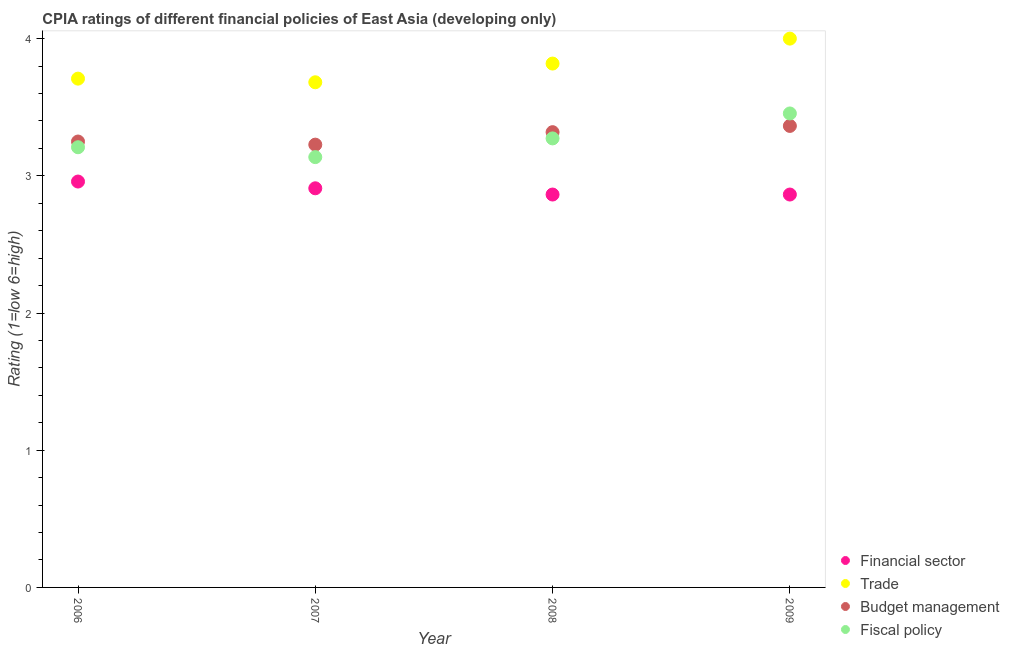Is the number of dotlines equal to the number of legend labels?
Provide a short and direct response. Yes. What is the cpia rating of fiscal policy in 2008?
Offer a terse response. 3.27. Across all years, what is the minimum cpia rating of budget management?
Keep it short and to the point. 3.23. In which year was the cpia rating of fiscal policy maximum?
Offer a terse response. 2009. What is the total cpia rating of financial sector in the graph?
Provide a short and direct response. 11.59. What is the difference between the cpia rating of budget management in 2007 and that in 2009?
Your response must be concise. -0.14. What is the difference between the cpia rating of budget management in 2007 and the cpia rating of fiscal policy in 2009?
Offer a terse response. -0.23. What is the average cpia rating of financial sector per year?
Make the answer very short. 2.9. In how many years, is the cpia rating of financial sector greater than 3.8?
Ensure brevity in your answer.  0. What is the ratio of the cpia rating of financial sector in 2007 to that in 2008?
Provide a short and direct response. 1.02. Is the cpia rating of trade in 2006 less than that in 2008?
Ensure brevity in your answer.  Yes. What is the difference between the highest and the second highest cpia rating of fiscal policy?
Make the answer very short. 0.18. What is the difference between the highest and the lowest cpia rating of trade?
Offer a terse response. 0.32. Is it the case that in every year, the sum of the cpia rating of financial sector and cpia rating of trade is greater than the cpia rating of budget management?
Provide a succinct answer. Yes. How many dotlines are there?
Give a very brief answer. 4. How many years are there in the graph?
Keep it short and to the point. 4. What is the difference between two consecutive major ticks on the Y-axis?
Keep it short and to the point. 1. Does the graph contain any zero values?
Your answer should be compact. No. How are the legend labels stacked?
Your answer should be compact. Vertical. What is the title of the graph?
Your response must be concise. CPIA ratings of different financial policies of East Asia (developing only). What is the Rating (1=low 6=high) in Financial sector in 2006?
Ensure brevity in your answer.  2.96. What is the Rating (1=low 6=high) of Trade in 2006?
Keep it short and to the point. 3.71. What is the Rating (1=low 6=high) of Fiscal policy in 2006?
Ensure brevity in your answer.  3.21. What is the Rating (1=low 6=high) in Financial sector in 2007?
Offer a terse response. 2.91. What is the Rating (1=low 6=high) in Trade in 2007?
Make the answer very short. 3.68. What is the Rating (1=low 6=high) in Budget management in 2007?
Ensure brevity in your answer.  3.23. What is the Rating (1=low 6=high) of Fiscal policy in 2007?
Your answer should be compact. 3.14. What is the Rating (1=low 6=high) in Financial sector in 2008?
Give a very brief answer. 2.86. What is the Rating (1=low 6=high) in Trade in 2008?
Ensure brevity in your answer.  3.82. What is the Rating (1=low 6=high) in Budget management in 2008?
Keep it short and to the point. 3.32. What is the Rating (1=low 6=high) in Fiscal policy in 2008?
Ensure brevity in your answer.  3.27. What is the Rating (1=low 6=high) in Financial sector in 2009?
Make the answer very short. 2.86. What is the Rating (1=low 6=high) in Budget management in 2009?
Give a very brief answer. 3.36. What is the Rating (1=low 6=high) in Fiscal policy in 2009?
Your response must be concise. 3.45. Across all years, what is the maximum Rating (1=low 6=high) of Financial sector?
Provide a short and direct response. 2.96. Across all years, what is the maximum Rating (1=low 6=high) in Trade?
Provide a short and direct response. 4. Across all years, what is the maximum Rating (1=low 6=high) of Budget management?
Make the answer very short. 3.36. Across all years, what is the maximum Rating (1=low 6=high) of Fiscal policy?
Your answer should be very brief. 3.45. Across all years, what is the minimum Rating (1=low 6=high) of Financial sector?
Your answer should be compact. 2.86. Across all years, what is the minimum Rating (1=low 6=high) in Trade?
Your answer should be compact. 3.68. Across all years, what is the minimum Rating (1=low 6=high) in Budget management?
Your answer should be very brief. 3.23. Across all years, what is the minimum Rating (1=low 6=high) of Fiscal policy?
Your answer should be very brief. 3.14. What is the total Rating (1=low 6=high) of Financial sector in the graph?
Your answer should be very brief. 11.59. What is the total Rating (1=low 6=high) of Trade in the graph?
Provide a succinct answer. 15.21. What is the total Rating (1=low 6=high) of Budget management in the graph?
Offer a terse response. 13.16. What is the total Rating (1=low 6=high) of Fiscal policy in the graph?
Make the answer very short. 13.07. What is the difference between the Rating (1=low 6=high) of Financial sector in 2006 and that in 2007?
Give a very brief answer. 0.05. What is the difference between the Rating (1=low 6=high) in Trade in 2006 and that in 2007?
Make the answer very short. 0.03. What is the difference between the Rating (1=low 6=high) of Budget management in 2006 and that in 2007?
Provide a short and direct response. 0.02. What is the difference between the Rating (1=low 6=high) of Fiscal policy in 2006 and that in 2007?
Keep it short and to the point. 0.07. What is the difference between the Rating (1=low 6=high) of Financial sector in 2006 and that in 2008?
Give a very brief answer. 0.09. What is the difference between the Rating (1=low 6=high) in Trade in 2006 and that in 2008?
Offer a very short reply. -0.11. What is the difference between the Rating (1=low 6=high) in Budget management in 2006 and that in 2008?
Provide a succinct answer. -0.07. What is the difference between the Rating (1=low 6=high) of Fiscal policy in 2006 and that in 2008?
Your answer should be compact. -0.06. What is the difference between the Rating (1=low 6=high) of Financial sector in 2006 and that in 2009?
Give a very brief answer. 0.09. What is the difference between the Rating (1=low 6=high) in Trade in 2006 and that in 2009?
Offer a terse response. -0.29. What is the difference between the Rating (1=low 6=high) of Budget management in 2006 and that in 2009?
Give a very brief answer. -0.11. What is the difference between the Rating (1=low 6=high) of Fiscal policy in 2006 and that in 2009?
Offer a very short reply. -0.25. What is the difference between the Rating (1=low 6=high) of Financial sector in 2007 and that in 2008?
Your answer should be compact. 0.05. What is the difference between the Rating (1=low 6=high) in Trade in 2007 and that in 2008?
Provide a short and direct response. -0.14. What is the difference between the Rating (1=low 6=high) of Budget management in 2007 and that in 2008?
Provide a succinct answer. -0.09. What is the difference between the Rating (1=low 6=high) of Fiscal policy in 2007 and that in 2008?
Ensure brevity in your answer.  -0.14. What is the difference between the Rating (1=low 6=high) in Financial sector in 2007 and that in 2009?
Provide a succinct answer. 0.05. What is the difference between the Rating (1=low 6=high) of Trade in 2007 and that in 2009?
Make the answer very short. -0.32. What is the difference between the Rating (1=low 6=high) in Budget management in 2007 and that in 2009?
Offer a very short reply. -0.14. What is the difference between the Rating (1=low 6=high) of Fiscal policy in 2007 and that in 2009?
Your answer should be very brief. -0.32. What is the difference between the Rating (1=low 6=high) of Trade in 2008 and that in 2009?
Offer a terse response. -0.18. What is the difference between the Rating (1=low 6=high) in Budget management in 2008 and that in 2009?
Ensure brevity in your answer.  -0.05. What is the difference between the Rating (1=low 6=high) of Fiscal policy in 2008 and that in 2009?
Offer a very short reply. -0.18. What is the difference between the Rating (1=low 6=high) in Financial sector in 2006 and the Rating (1=low 6=high) in Trade in 2007?
Offer a terse response. -0.72. What is the difference between the Rating (1=low 6=high) of Financial sector in 2006 and the Rating (1=low 6=high) of Budget management in 2007?
Make the answer very short. -0.27. What is the difference between the Rating (1=low 6=high) in Financial sector in 2006 and the Rating (1=low 6=high) in Fiscal policy in 2007?
Provide a succinct answer. -0.18. What is the difference between the Rating (1=low 6=high) in Trade in 2006 and the Rating (1=low 6=high) in Budget management in 2007?
Offer a very short reply. 0.48. What is the difference between the Rating (1=low 6=high) of Trade in 2006 and the Rating (1=low 6=high) of Fiscal policy in 2007?
Your answer should be very brief. 0.57. What is the difference between the Rating (1=low 6=high) of Budget management in 2006 and the Rating (1=low 6=high) of Fiscal policy in 2007?
Your response must be concise. 0.11. What is the difference between the Rating (1=low 6=high) in Financial sector in 2006 and the Rating (1=low 6=high) in Trade in 2008?
Give a very brief answer. -0.86. What is the difference between the Rating (1=low 6=high) of Financial sector in 2006 and the Rating (1=low 6=high) of Budget management in 2008?
Your answer should be very brief. -0.36. What is the difference between the Rating (1=low 6=high) of Financial sector in 2006 and the Rating (1=low 6=high) of Fiscal policy in 2008?
Offer a very short reply. -0.31. What is the difference between the Rating (1=low 6=high) in Trade in 2006 and the Rating (1=low 6=high) in Budget management in 2008?
Offer a very short reply. 0.39. What is the difference between the Rating (1=low 6=high) in Trade in 2006 and the Rating (1=low 6=high) in Fiscal policy in 2008?
Offer a very short reply. 0.44. What is the difference between the Rating (1=low 6=high) in Budget management in 2006 and the Rating (1=low 6=high) in Fiscal policy in 2008?
Keep it short and to the point. -0.02. What is the difference between the Rating (1=low 6=high) in Financial sector in 2006 and the Rating (1=low 6=high) in Trade in 2009?
Give a very brief answer. -1.04. What is the difference between the Rating (1=low 6=high) of Financial sector in 2006 and the Rating (1=low 6=high) of Budget management in 2009?
Your answer should be compact. -0.41. What is the difference between the Rating (1=low 6=high) in Financial sector in 2006 and the Rating (1=low 6=high) in Fiscal policy in 2009?
Provide a short and direct response. -0.5. What is the difference between the Rating (1=low 6=high) of Trade in 2006 and the Rating (1=low 6=high) of Budget management in 2009?
Offer a very short reply. 0.34. What is the difference between the Rating (1=low 6=high) in Trade in 2006 and the Rating (1=low 6=high) in Fiscal policy in 2009?
Offer a terse response. 0.25. What is the difference between the Rating (1=low 6=high) in Budget management in 2006 and the Rating (1=low 6=high) in Fiscal policy in 2009?
Provide a succinct answer. -0.2. What is the difference between the Rating (1=low 6=high) in Financial sector in 2007 and the Rating (1=low 6=high) in Trade in 2008?
Make the answer very short. -0.91. What is the difference between the Rating (1=low 6=high) in Financial sector in 2007 and the Rating (1=low 6=high) in Budget management in 2008?
Your response must be concise. -0.41. What is the difference between the Rating (1=low 6=high) of Financial sector in 2007 and the Rating (1=low 6=high) of Fiscal policy in 2008?
Ensure brevity in your answer.  -0.36. What is the difference between the Rating (1=low 6=high) in Trade in 2007 and the Rating (1=low 6=high) in Budget management in 2008?
Your response must be concise. 0.36. What is the difference between the Rating (1=low 6=high) of Trade in 2007 and the Rating (1=low 6=high) of Fiscal policy in 2008?
Provide a short and direct response. 0.41. What is the difference between the Rating (1=low 6=high) in Budget management in 2007 and the Rating (1=low 6=high) in Fiscal policy in 2008?
Offer a very short reply. -0.05. What is the difference between the Rating (1=low 6=high) in Financial sector in 2007 and the Rating (1=low 6=high) in Trade in 2009?
Provide a succinct answer. -1.09. What is the difference between the Rating (1=low 6=high) of Financial sector in 2007 and the Rating (1=low 6=high) of Budget management in 2009?
Provide a short and direct response. -0.45. What is the difference between the Rating (1=low 6=high) of Financial sector in 2007 and the Rating (1=low 6=high) of Fiscal policy in 2009?
Keep it short and to the point. -0.55. What is the difference between the Rating (1=low 6=high) of Trade in 2007 and the Rating (1=low 6=high) of Budget management in 2009?
Offer a very short reply. 0.32. What is the difference between the Rating (1=low 6=high) of Trade in 2007 and the Rating (1=low 6=high) of Fiscal policy in 2009?
Offer a terse response. 0.23. What is the difference between the Rating (1=low 6=high) in Budget management in 2007 and the Rating (1=low 6=high) in Fiscal policy in 2009?
Offer a very short reply. -0.23. What is the difference between the Rating (1=low 6=high) in Financial sector in 2008 and the Rating (1=low 6=high) in Trade in 2009?
Offer a very short reply. -1.14. What is the difference between the Rating (1=low 6=high) in Financial sector in 2008 and the Rating (1=low 6=high) in Fiscal policy in 2009?
Make the answer very short. -0.59. What is the difference between the Rating (1=low 6=high) of Trade in 2008 and the Rating (1=low 6=high) of Budget management in 2009?
Give a very brief answer. 0.45. What is the difference between the Rating (1=low 6=high) of Trade in 2008 and the Rating (1=low 6=high) of Fiscal policy in 2009?
Provide a short and direct response. 0.36. What is the difference between the Rating (1=low 6=high) in Budget management in 2008 and the Rating (1=low 6=high) in Fiscal policy in 2009?
Provide a short and direct response. -0.14. What is the average Rating (1=low 6=high) of Financial sector per year?
Give a very brief answer. 2.9. What is the average Rating (1=low 6=high) of Trade per year?
Your response must be concise. 3.8. What is the average Rating (1=low 6=high) in Budget management per year?
Provide a succinct answer. 3.29. What is the average Rating (1=low 6=high) in Fiscal policy per year?
Your response must be concise. 3.27. In the year 2006, what is the difference between the Rating (1=low 6=high) in Financial sector and Rating (1=low 6=high) in Trade?
Make the answer very short. -0.75. In the year 2006, what is the difference between the Rating (1=low 6=high) of Financial sector and Rating (1=low 6=high) of Budget management?
Make the answer very short. -0.29. In the year 2006, what is the difference between the Rating (1=low 6=high) of Trade and Rating (1=low 6=high) of Budget management?
Ensure brevity in your answer.  0.46. In the year 2006, what is the difference between the Rating (1=low 6=high) in Budget management and Rating (1=low 6=high) in Fiscal policy?
Ensure brevity in your answer.  0.04. In the year 2007, what is the difference between the Rating (1=low 6=high) of Financial sector and Rating (1=low 6=high) of Trade?
Your response must be concise. -0.77. In the year 2007, what is the difference between the Rating (1=low 6=high) of Financial sector and Rating (1=low 6=high) of Budget management?
Offer a very short reply. -0.32. In the year 2007, what is the difference between the Rating (1=low 6=high) in Financial sector and Rating (1=low 6=high) in Fiscal policy?
Offer a terse response. -0.23. In the year 2007, what is the difference between the Rating (1=low 6=high) of Trade and Rating (1=low 6=high) of Budget management?
Provide a succinct answer. 0.45. In the year 2007, what is the difference between the Rating (1=low 6=high) of Trade and Rating (1=low 6=high) of Fiscal policy?
Keep it short and to the point. 0.55. In the year 2007, what is the difference between the Rating (1=low 6=high) of Budget management and Rating (1=low 6=high) of Fiscal policy?
Keep it short and to the point. 0.09. In the year 2008, what is the difference between the Rating (1=low 6=high) of Financial sector and Rating (1=low 6=high) of Trade?
Offer a very short reply. -0.95. In the year 2008, what is the difference between the Rating (1=low 6=high) in Financial sector and Rating (1=low 6=high) in Budget management?
Offer a terse response. -0.45. In the year 2008, what is the difference between the Rating (1=low 6=high) of Financial sector and Rating (1=low 6=high) of Fiscal policy?
Keep it short and to the point. -0.41. In the year 2008, what is the difference between the Rating (1=low 6=high) in Trade and Rating (1=low 6=high) in Fiscal policy?
Offer a terse response. 0.55. In the year 2008, what is the difference between the Rating (1=low 6=high) of Budget management and Rating (1=low 6=high) of Fiscal policy?
Give a very brief answer. 0.05. In the year 2009, what is the difference between the Rating (1=low 6=high) in Financial sector and Rating (1=low 6=high) in Trade?
Provide a short and direct response. -1.14. In the year 2009, what is the difference between the Rating (1=low 6=high) of Financial sector and Rating (1=low 6=high) of Budget management?
Provide a succinct answer. -0.5. In the year 2009, what is the difference between the Rating (1=low 6=high) of Financial sector and Rating (1=low 6=high) of Fiscal policy?
Ensure brevity in your answer.  -0.59. In the year 2009, what is the difference between the Rating (1=low 6=high) in Trade and Rating (1=low 6=high) in Budget management?
Provide a short and direct response. 0.64. In the year 2009, what is the difference between the Rating (1=low 6=high) in Trade and Rating (1=low 6=high) in Fiscal policy?
Ensure brevity in your answer.  0.55. In the year 2009, what is the difference between the Rating (1=low 6=high) of Budget management and Rating (1=low 6=high) of Fiscal policy?
Provide a short and direct response. -0.09. What is the ratio of the Rating (1=low 6=high) of Financial sector in 2006 to that in 2007?
Offer a terse response. 1.02. What is the ratio of the Rating (1=low 6=high) of Trade in 2006 to that in 2007?
Your answer should be compact. 1.01. What is the ratio of the Rating (1=low 6=high) of Budget management in 2006 to that in 2007?
Make the answer very short. 1.01. What is the ratio of the Rating (1=low 6=high) of Fiscal policy in 2006 to that in 2007?
Your answer should be very brief. 1.02. What is the ratio of the Rating (1=low 6=high) of Financial sector in 2006 to that in 2008?
Your answer should be compact. 1.03. What is the ratio of the Rating (1=low 6=high) in Trade in 2006 to that in 2008?
Offer a very short reply. 0.97. What is the ratio of the Rating (1=low 6=high) of Budget management in 2006 to that in 2008?
Make the answer very short. 0.98. What is the ratio of the Rating (1=low 6=high) of Fiscal policy in 2006 to that in 2008?
Offer a very short reply. 0.98. What is the ratio of the Rating (1=low 6=high) in Financial sector in 2006 to that in 2009?
Provide a succinct answer. 1.03. What is the ratio of the Rating (1=low 6=high) of Trade in 2006 to that in 2009?
Your response must be concise. 0.93. What is the ratio of the Rating (1=low 6=high) of Budget management in 2006 to that in 2009?
Make the answer very short. 0.97. What is the ratio of the Rating (1=low 6=high) in Fiscal policy in 2006 to that in 2009?
Your answer should be very brief. 0.93. What is the ratio of the Rating (1=low 6=high) in Financial sector in 2007 to that in 2008?
Provide a succinct answer. 1.02. What is the ratio of the Rating (1=low 6=high) of Trade in 2007 to that in 2008?
Provide a short and direct response. 0.96. What is the ratio of the Rating (1=low 6=high) of Budget management in 2007 to that in 2008?
Your answer should be very brief. 0.97. What is the ratio of the Rating (1=low 6=high) in Fiscal policy in 2007 to that in 2008?
Provide a short and direct response. 0.96. What is the ratio of the Rating (1=low 6=high) of Financial sector in 2007 to that in 2009?
Provide a short and direct response. 1.02. What is the ratio of the Rating (1=low 6=high) of Trade in 2007 to that in 2009?
Provide a short and direct response. 0.92. What is the ratio of the Rating (1=low 6=high) of Budget management in 2007 to that in 2009?
Provide a short and direct response. 0.96. What is the ratio of the Rating (1=low 6=high) in Fiscal policy in 2007 to that in 2009?
Provide a succinct answer. 0.91. What is the ratio of the Rating (1=low 6=high) in Trade in 2008 to that in 2009?
Offer a terse response. 0.95. What is the ratio of the Rating (1=low 6=high) in Budget management in 2008 to that in 2009?
Ensure brevity in your answer.  0.99. What is the ratio of the Rating (1=low 6=high) in Fiscal policy in 2008 to that in 2009?
Provide a succinct answer. 0.95. What is the difference between the highest and the second highest Rating (1=low 6=high) in Financial sector?
Provide a succinct answer. 0.05. What is the difference between the highest and the second highest Rating (1=low 6=high) of Trade?
Offer a very short reply. 0.18. What is the difference between the highest and the second highest Rating (1=low 6=high) of Budget management?
Offer a very short reply. 0.05. What is the difference between the highest and the second highest Rating (1=low 6=high) in Fiscal policy?
Ensure brevity in your answer.  0.18. What is the difference between the highest and the lowest Rating (1=low 6=high) of Financial sector?
Your answer should be compact. 0.09. What is the difference between the highest and the lowest Rating (1=low 6=high) in Trade?
Make the answer very short. 0.32. What is the difference between the highest and the lowest Rating (1=low 6=high) in Budget management?
Provide a succinct answer. 0.14. What is the difference between the highest and the lowest Rating (1=low 6=high) in Fiscal policy?
Give a very brief answer. 0.32. 